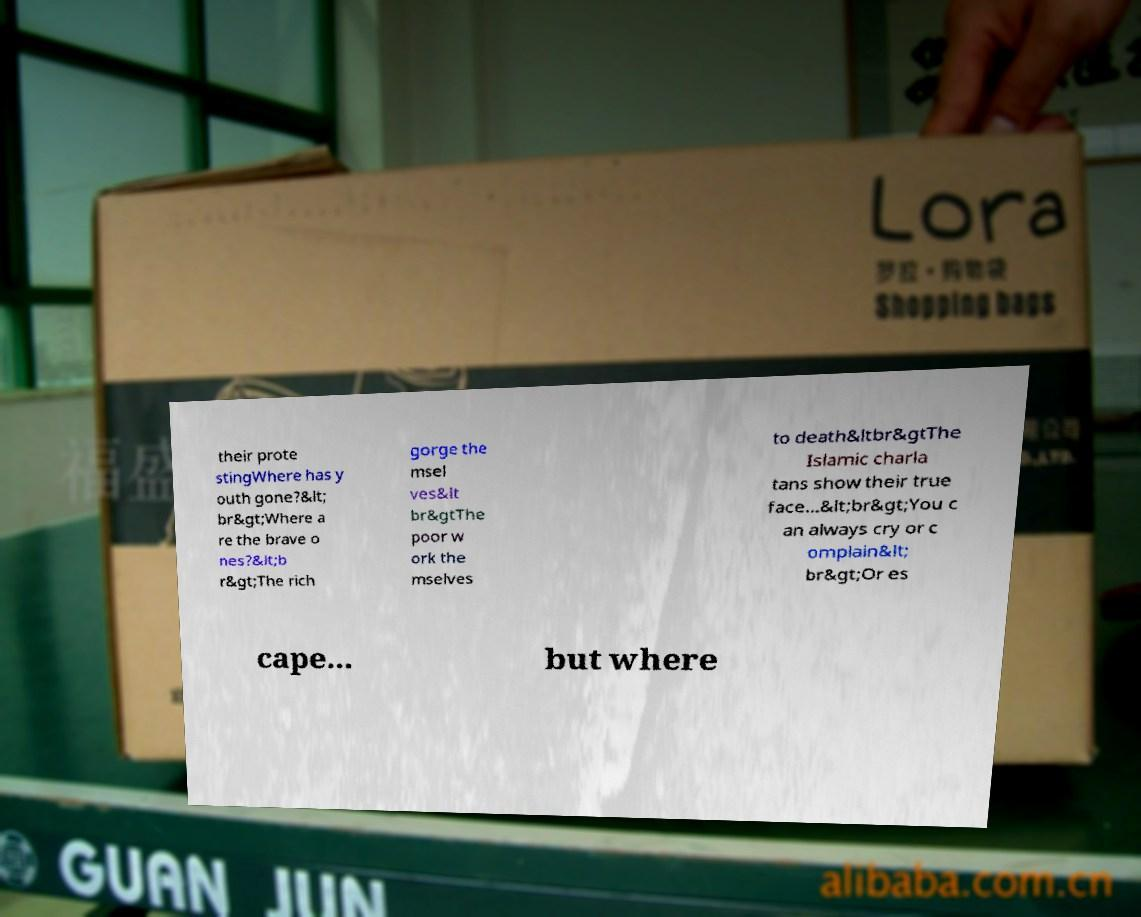Could you assist in decoding the text presented in this image and type it out clearly? their prote stingWhere has y outh gone?&lt; br&gt;Where a re the brave o nes?&lt;b r&gt;The rich gorge the msel ves&lt br&gtThe poor w ork the mselves to death&ltbr&gtThe Islamic charla tans show their true face...&lt;br&gt;You c an always cry or c omplain&lt; br&gt;Or es cape... but where 